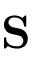Convert formula to latex. <formula><loc_0><loc_0><loc_500><loc_500>S</formula> 